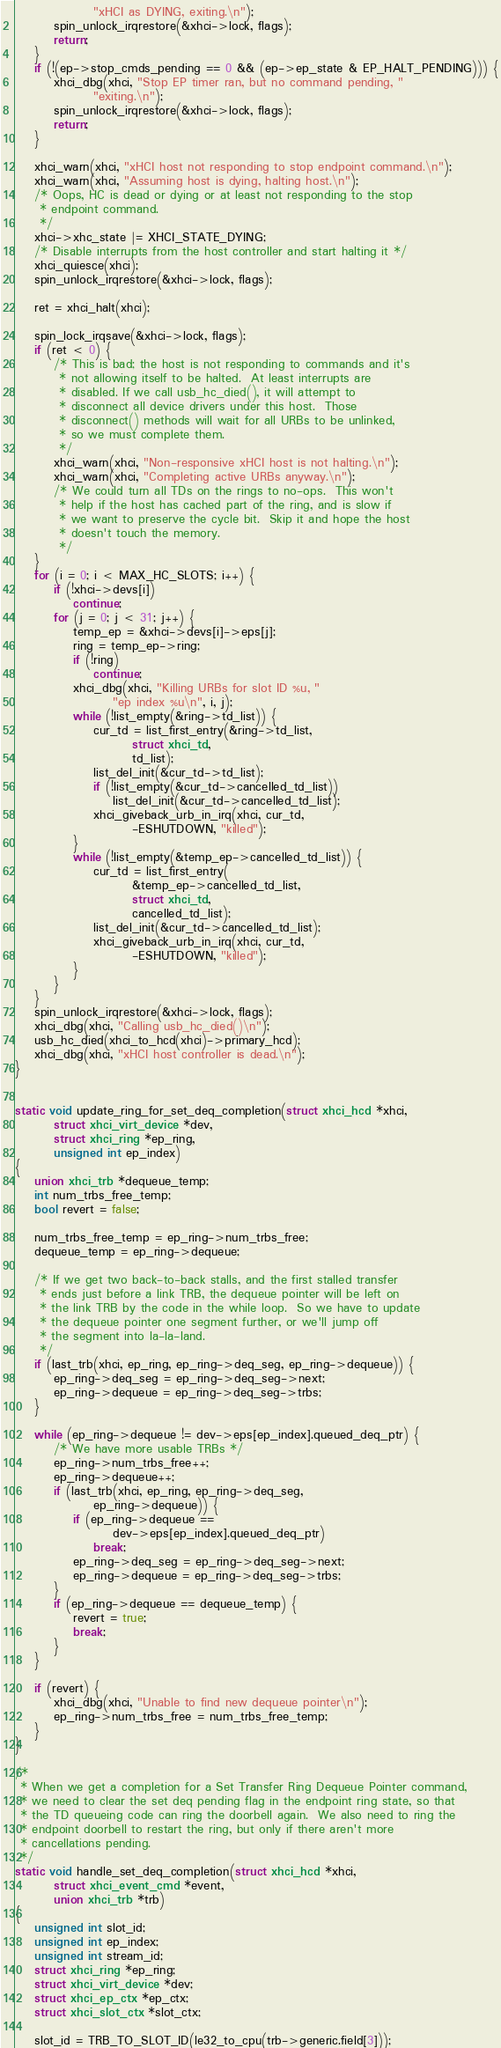Convert code to text. <code><loc_0><loc_0><loc_500><loc_500><_C_>				"xHCI as DYING, exiting.\n");
		spin_unlock_irqrestore(&xhci->lock, flags);
		return;
	}
	if (!(ep->stop_cmds_pending == 0 && (ep->ep_state & EP_HALT_PENDING))) {
		xhci_dbg(xhci, "Stop EP timer ran, but no command pending, "
				"exiting.\n");
		spin_unlock_irqrestore(&xhci->lock, flags);
		return;
	}

	xhci_warn(xhci, "xHCI host not responding to stop endpoint command.\n");
	xhci_warn(xhci, "Assuming host is dying, halting host.\n");
	/* Oops, HC is dead or dying or at least not responding to the stop
	 * endpoint command.
	 */
	xhci->xhc_state |= XHCI_STATE_DYING;
	/* Disable interrupts from the host controller and start halting it */
	xhci_quiesce(xhci);
	spin_unlock_irqrestore(&xhci->lock, flags);

	ret = xhci_halt(xhci);

	spin_lock_irqsave(&xhci->lock, flags);
	if (ret < 0) {
		/* This is bad; the host is not responding to commands and it's
		 * not allowing itself to be halted.  At least interrupts are
		 * disabled. If we call usb_hc_died(), it will attempt to
		 * disconnect all device drivers under this host.  Those
		 * disconnect() methods will wait for all URBs to be unlinked,
		 * so we must complete them.
		 */
		xhci_warn(xhci, "Non-responsive xHCI host is not halting.\n");
		xhci_warn(xhci, "Completing active URBs anyway.\n");
		/* We could turn all TDs on the rings to no-ops.  This won't
		 * help if the host has cached part of the ring, and is slow if
		 * we want to preserve the cycle bit.  Skip it and hope the host
		 * doesn't touch the memory.
		 */
	}
	for (i = 0; i < MAX_HC_SLOTS; i++) {
		if (!xhci->devs[i])
			continue;
		for (j = 0; j < 31; j++) {
			temp_ep = &xhci->devs[i]->eps[j];
			ring = temp_ep->ring;
			if (!ring)
				continue;
			xhci_dbg(xhci, "Killing URBs for slot ID %u, "
					"ep index %u\n", i, j);
			while (!list_empty(&ring->td_list)) {
				cur_td = list_first_entry(&ring->td_list,
						struct xhci_td,
						td_list);
				list_del_init(&cur_td->td_list);
				if (!list_empty(&cur_td->cancelled_td_list))
					list_del_init(&cur_td->cancelled_td_list);
				xhci_giveback_urb_in_irq(xhci, cur_td,
						-ESHUTDOWN, "killed");
			}
			while (!list_empty(&temp_ep->cancelled_td_list)) {
				cur_td = list_first_entry(
						&temp_ep->cancelled_td_list,
						struct xhci_td,
						cancelled_td_list);
				list_del_init(&cur_td->cancelled_td_list);
				xhci_giveback_urb_in_irq(xhci, cur_td,
						-ESHUTDOWN, "killed");
			}
		}
	}
	spin_unlock_irqrestore(&xhci->lock, flags);
	xhci_dbg(xhci, "Calling usb_hc_died()\n");
	usb_hc_died(xhci_to_hcd(xhci)->primary_hcd);
	xhci_dbg(xhci, "xHCI host controller is dead.\n");
}


static void update_ring_for_set_deq_completion(struct xhci_hcd *xhci,
		struct xhci_virt_device *dev,
		struct xhci_ring *ep_ring,
		unsigned int ep_index)
{
	union xhci_trb *dequeue_temp;
	int num_trbs_free_temp;
	bool revert = false;

	num_trbs_free_temp = ep_ring->num_trbs_free;
	dequeue_temp = ep_ring->dequeue;

	/* If we get two back-to-back stalls, and the first stalled transfer
	 * ends just before a link TRB, the dequeue pointer will be left on
	 * the link TRB by the code in the while loop.  So we have to update
	 * the dequeue pointer one segment further, or we'll jump off
	 * the segment into la-la-land.
	 */
	if (last_trb(xhci, ep_ring, ep_ring->deq_seg, ep_ring->dequeue)) {
		ep_ring->deq_seg = ep_ring->deq_seg->next;
		ep_ring->dequeue = ep_ring->deq_seg->trbs;
	}

	while (ep_ring->dequeue != dev->eps[ep_index].queued_deq_ptr) {
		/* We have more usable TRBs */
		ep_ring->num_trbs_free++;
		ep_ring->dequeue++;
		if (last_trb(xhci, ep_ring, ep_ring->deq_seg,
				ep_ring->dequeue)) {
			if (ep_ring->dequeue ==
					dev->eps[ep_index].queued_deq_ptr)
				break;
			ep_ring->deq_seg = ep_ring->deq_seg->next;
			ep_ring->dequeue = ep_ring->deq_seg->trbs;
		}
		if (ep_ring->dequeue == dequeue_temp) {
			revert = true;
			break;
		}
	}

	if (revert) {
		xhci_dbg(xhci, "Unable to find new dequeue pointer\n");
		ep_ring->num_trbs_free = num_trbs_free_temp;
	}
}

/*
 * When we get a completion for a Set Transfer Ring Dequeue Pointer command,
 * we need to clear the set deq pending flag in the endpoint ring state, so that
 * the TD queueing code can ring the doorbell again.  We also need to ring the
 * endpoint doorbell to restart the ring, but only if there aren't more
 * cancellations pending.
 */
static void handle_set_deq_completion(struct xhci_hcd *xhci,
		struct xhci_event_cmd *event,
		union xhci_trb *trb)
{
	unsigned int slot_id;
	unsigned int ep_index;
	unsigned int stream_id;
	struct xhci_ring *ep_ring;
	struct xhci_virt_device *dev;
	struct xhci_ep_ctx *ep_ctx;
	struct xhci_slot_ctx *slot_ctx;

	slot_id = TRB_TO_SLOT_ID(le32_to_cpu(trb->generic.field[3]));</code> 